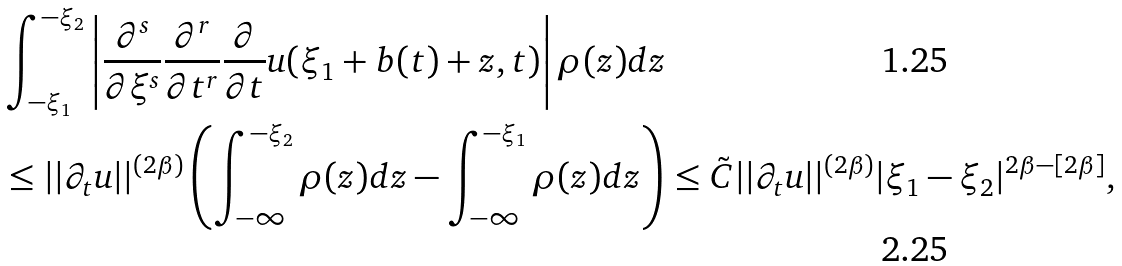Convert formula to latex. <formula><loc_0><loc_0><loc_500><loc_500>& \int _ { - \xi _ { 1 } } ^ { - \xi _ { 2 } } \left | \frac { \partial ^ { s } } { \partial \xi ^ { s } } \frac { \partial ^ { r } } { \partial t ^ { r } } \frac { \partial } { \partial t } u ( \xi _ { 1 } + b ( t ) + z , t ) \right | \rho ( z ) d z \\ & \leq | | \partial _ { t } u | | ^ { ( 2 \beta ) } \left ( \int _ { - \infty } ^ { - \xi _ { 2 } } \rho ( z ) d z - \int _ { - \infty } ^ { - \xi _ { 1 } } \rho ( z ) d z \right ) \leq \tilde { C } | | \partial _ { t } u | | ^ { ( 2 \beta ) } | \xi _ { 1 } - \xi _ { 2 } | ^ { 2 \beta - [ 2 \beta ] } ,</formula> 